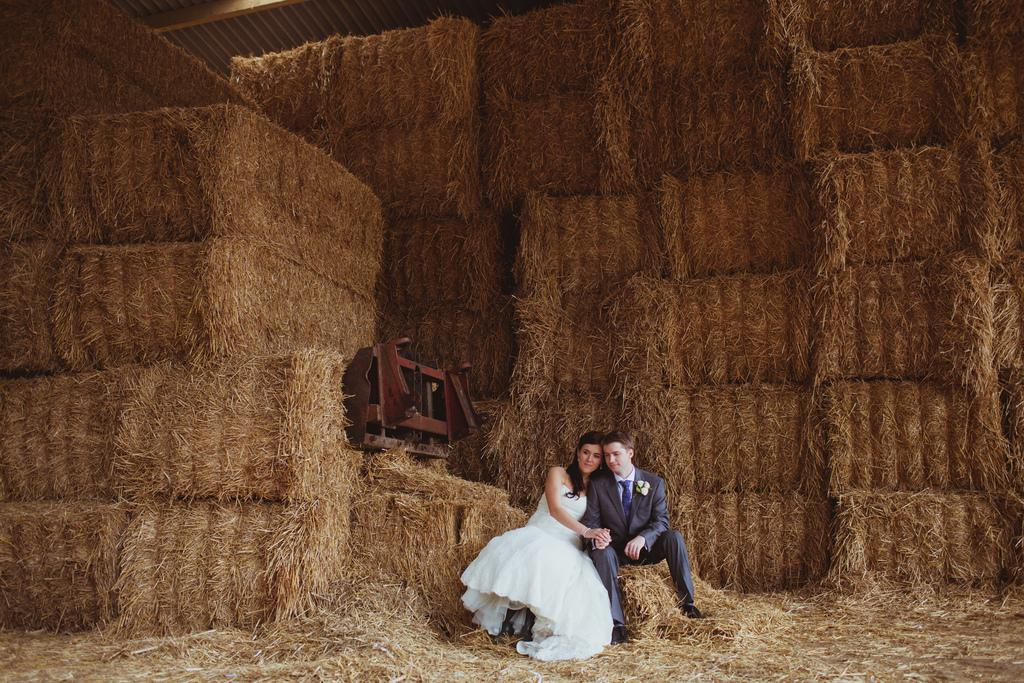Who is present in the image? There is a lady and a man in the image. What are the lady and the man doing in the image? Both the lady and the man are sitting on hay. What can be seen in the background of the image? There are piles of hay in the background of the image. What other object is present in the image? There is a machine in the image. Can you hear the lady's voice in the image? There is no sound or voice present in the image, as it is a still photograph. 